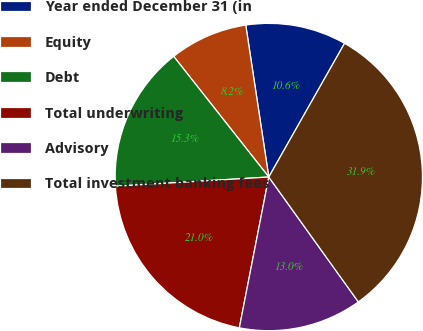Convert chart to OTSL. <chart><loc_0><loc_0><loc_500><loc_500><pie_chart><fcel>Year ended December 31 (in<fcel>Equity<fcel>Debt<fcel>Total underwriting<fcel>Advisory<fcel>Total investment banking fees<nl><fcel>10.6%<fcel>8.23%<fcel>15.33%<fcel>20.97%<fcel>12.97%<fcel>31.89%<nl></chart> 